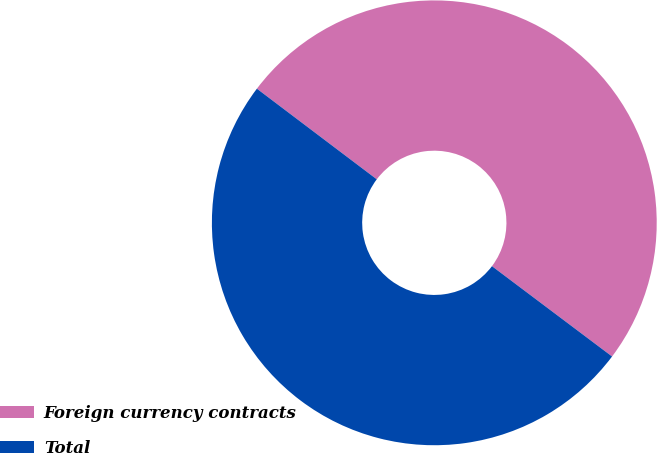Convert chart to OTSL. <chart><loc_0><loc_0><loc_500><loc_500><pie_chart><fcel>Foreign currency contracts<fcel>Total<nl><fcel>49.96%<fcel>50.04%<nl></chart> 